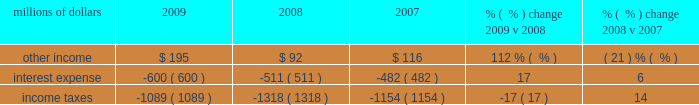An adverse development with respect to one claim in 2008 and favorable developments in three cases in 2009 .
Other costs were also lower in 2009 compared to 2008 , driven by a decrease in expenses for freight and property damages , employee travel , and utilities .
In addition , higher bad debt expense in 2008 due to the uncertain impact of the recessionary economy drove a favorable year-over-year comparison .
Conversely , an additional expense of $ 30 million related to a transaction with pacer international , inc .
And higher property taxes partially offset lower costs in 2009 .
Other costs were higher in 2008 compared to 2007 due to an increase in bad debts , state and local taxes , loss and damage expenses , utility costs , and other miscellaneous expenses totaling $ 122 million .
Conversely , personal injury costs ( including asbestos-related claims ) were $ 8 million lower in 2008 compared to 2007 .
The reduction reflects improvements in our safety experience and lower estimated costs to resolve claims as indicated in the actuarial studies of our personal injury expense and annual reviews of asbestos-related claims in both 2008 and 2007 .
The year-over-year comparison also includes the negative impact of adverse development associated with one claim in 2008 .
In addition , environmental and toxic tort expenses were $ 7 million lower in 2008 compared to 2007 .
Non-operating items millions of dollars 2009 2008 2007 % (  % ) change 2009 v 2008 % (  % ) change 2008 v 2007 .
Other income 2013 other income increased $ 103 million in 2009 compared to 2008 primarily due to higher gains from real estate sales , which included the $ 116 million pre-tax gain from a land sale to the regional transportation district ( rtd ) in colorado and lower interest expense on our sale of receivables program , resulting from lower interest rates and a lower outstanding balance .
Reduced rental and licensing income and lower returns on cash investments , reflecting lower interest rates , partially offset these increases .
Other income decreased in 2008 compared to 2007 due to lower gains from real estate sales and decreased returns on cash investments reflecting lower interest rates .
Higher rental and licensing income and lower interest expense on our sale of receivables program partially offset the decreases .
Interest expense 2013 interest expense increased in 2009 versus 2008 due primarily to higher weighted- average debt levels .
In 2009 , the weighted-average debt level was $ 9.6 billion ( including the restructuring of locomotive leases in may of 2009 ) , compared to $ 8.3 billion in 2008 .
Our effective interest rate was 6.3% ( 6.3 % ) in 2009 , compared to 6.1% ( 6.1 % ) in 2008 .
Interest expense increased in 2008 versus 2007 due to a higher weighted-average debt level of $ 8.3 billion , compared to $ 7.3 billion in 2007 .
A lower effective interest rate of 6.1% ( 6.1 % ) in 2008 , compared to 6.6% ( 6.6 % ) in 2007 , partially offset the effects of the higher weighted-average debt level .
Income taxes 2013 income taxes were lower in 2009 compared to 2008 , driven by lower pre-tax income .
Our effective tax rate for the year was 36.5% ( 36.5 % ) compared to 36.1% ( 36.1 % ) in 2008 .
Income taxes were higher in 2008 compared to 2007 , driven by higher pre-tax income .
Our effective tax rates were 36.1% ( 36.1 % ) and 38.4% ( 38.4 % ) in 2008 and 2007 , respectively .
The lower effective tax rate in 2008 resulted from several reductions in tax expense related to federal audits and state tax law changes .
In addition , the effective tax rate in 2007 was increased by illinois legislation that increased deferred tax expense in the third quarter of 2007. .
If the 2009 weighted-average debt level had the same weighted average interest rate as 2008 , what would interest expense have been , in millions? 
Computations: ((9.6 * 6.1%) * 1000)
Answer: 585.6. 